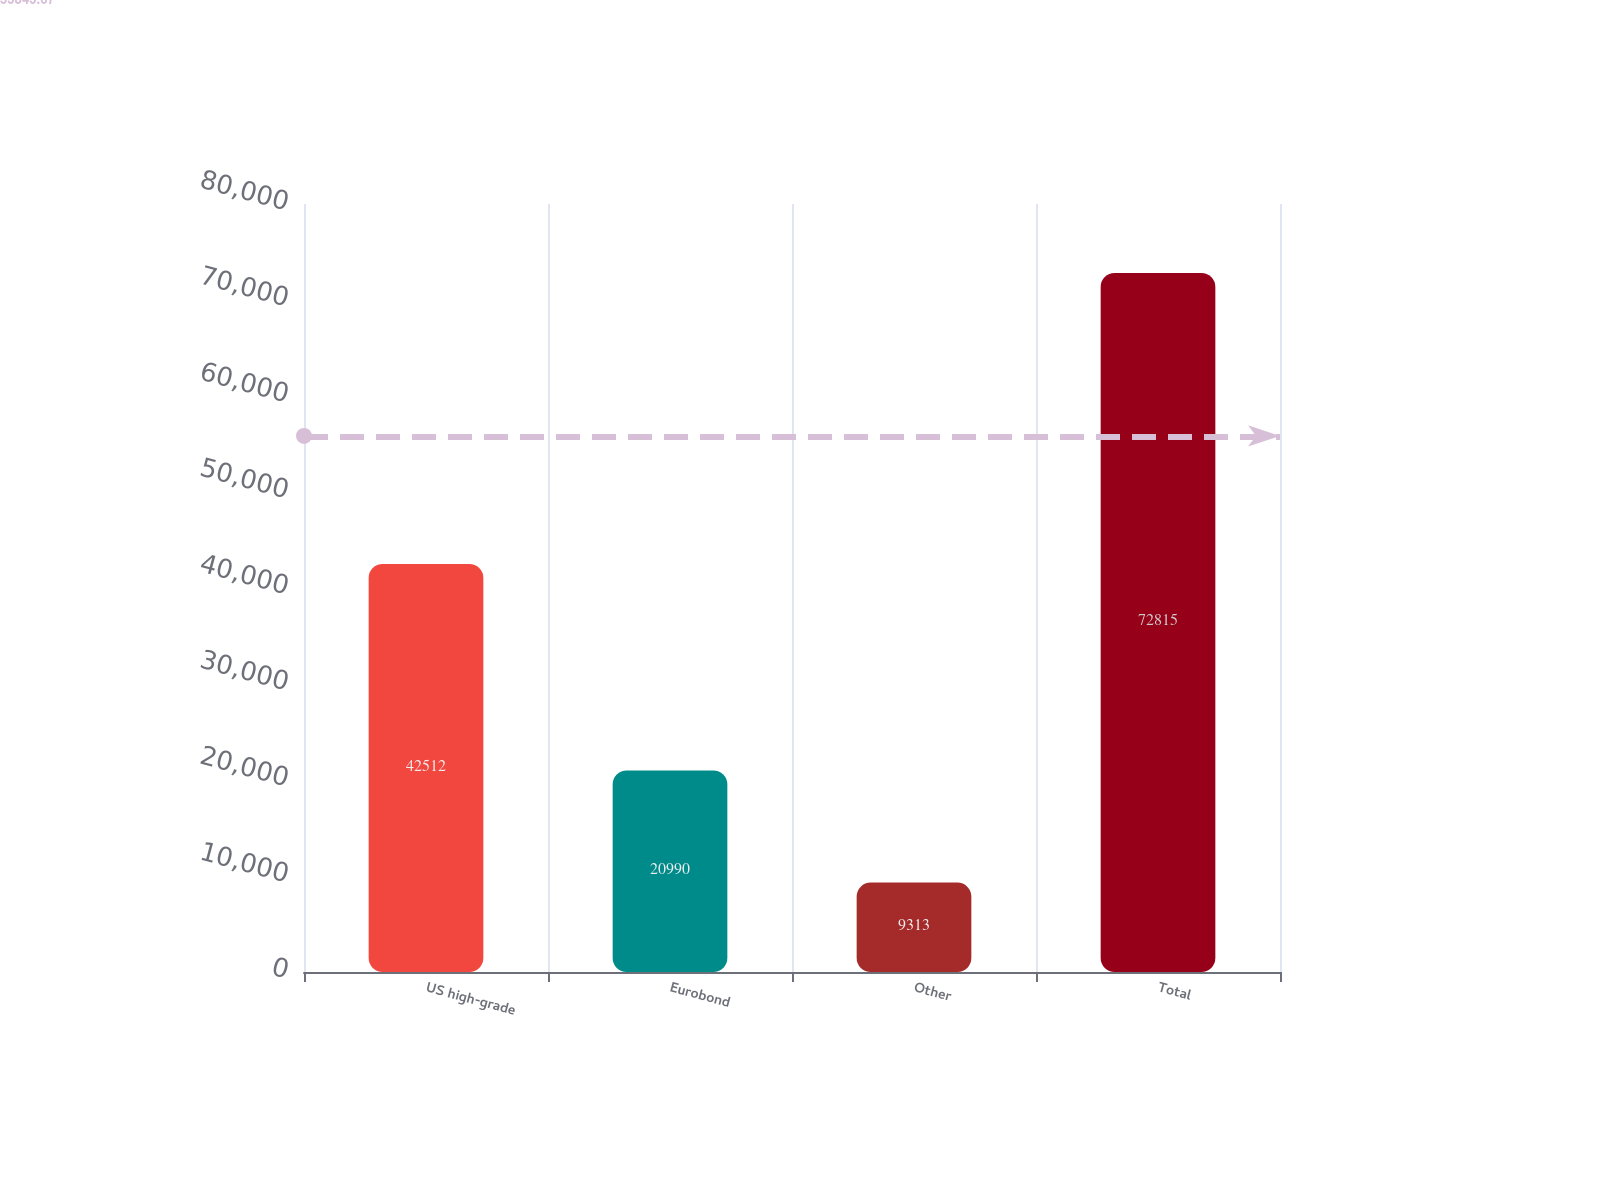Convert chart. <chart><loc_0><loc_0><loc_500><loc_500><bar_chart><fcel>US high-grade<fcel>Eurobond<fcel>Other<fcel>Total<nl><fcel>42512<fcel>20990<fcel>9313<fcel>72815<nl></chart> 